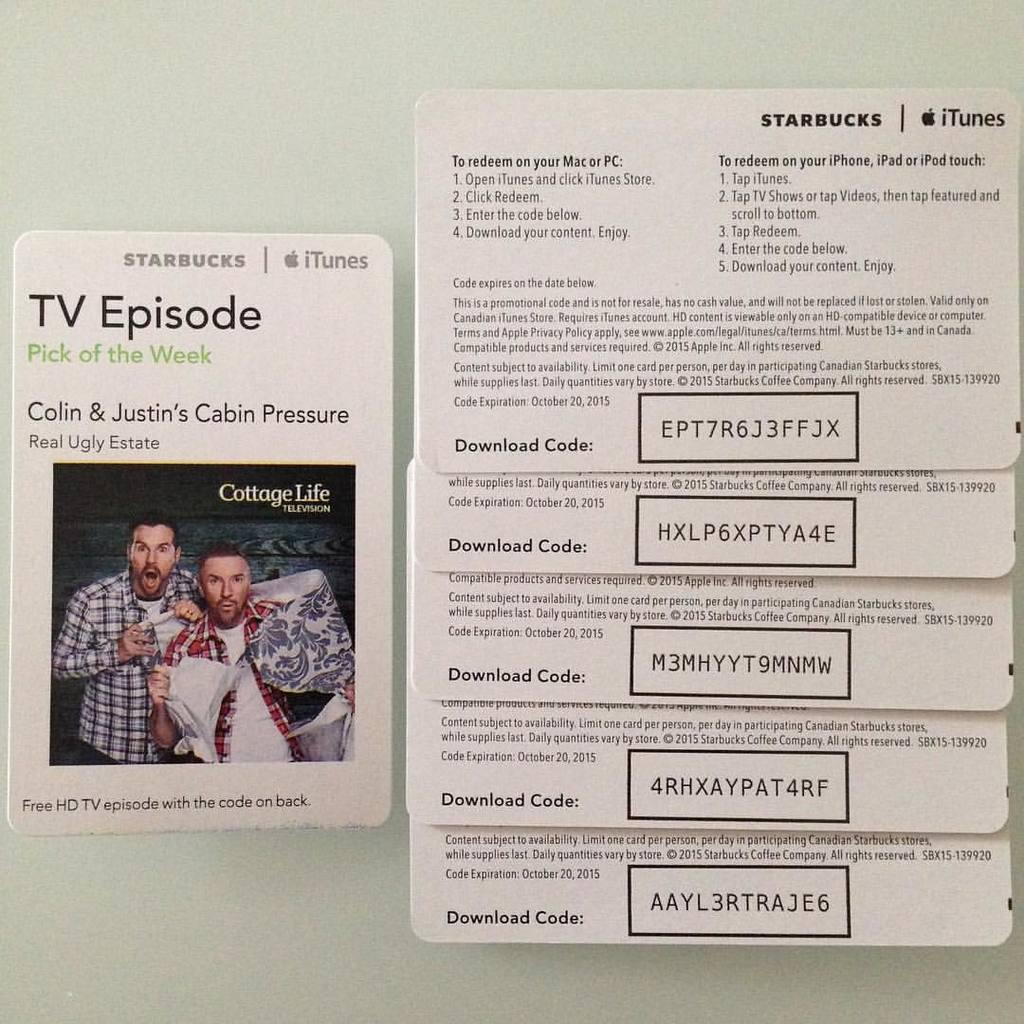What type of objects are in the image? There are cards in the image. What can be found on the cards? The cards have text, boxes, numerical numbers, and images on them. What is the background of the image? The cards are placed on a white surface. Can you see any waves in the image? There are no waves present in the image; it features cards on a white surface. Is there an airplane visible in the image? No, there is no airplane in the image. 